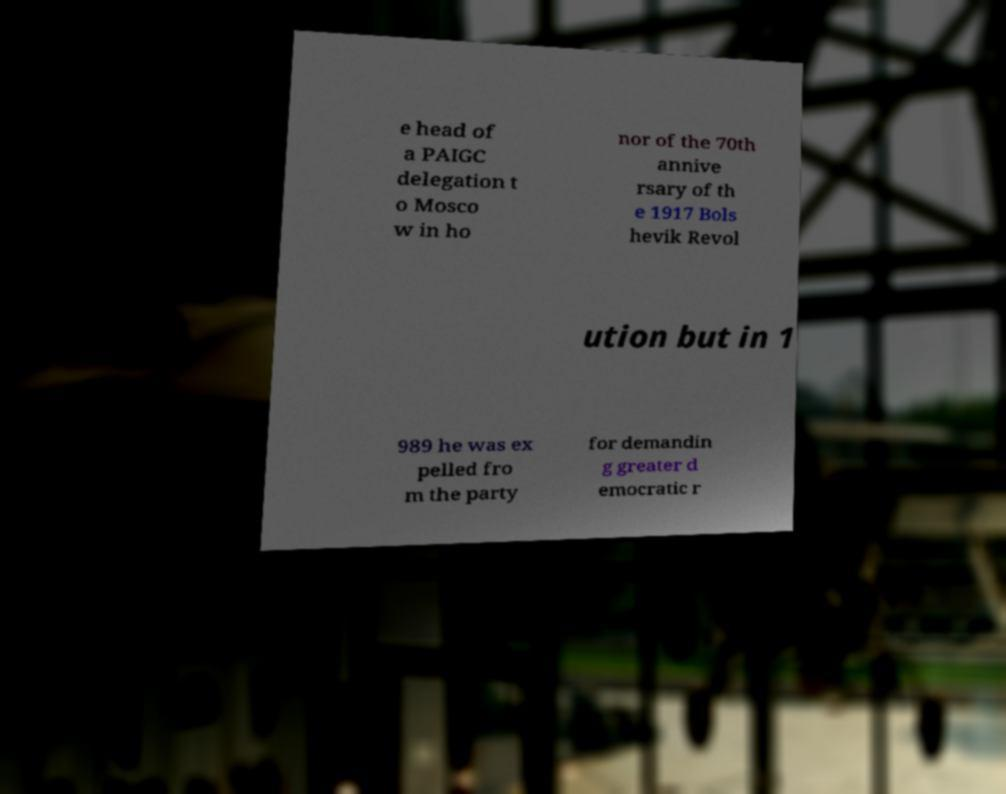For documentation purposes, I need the text within this image transcribed. Could you provide that? e head of a PAIGC delegation t o Mosco w in ho nor of the 70th annive rsary of th e 1917 Bols hevik Revol ution but in 1 989 he was ex pelled fro m the party for demandin g greater d emocratic r 